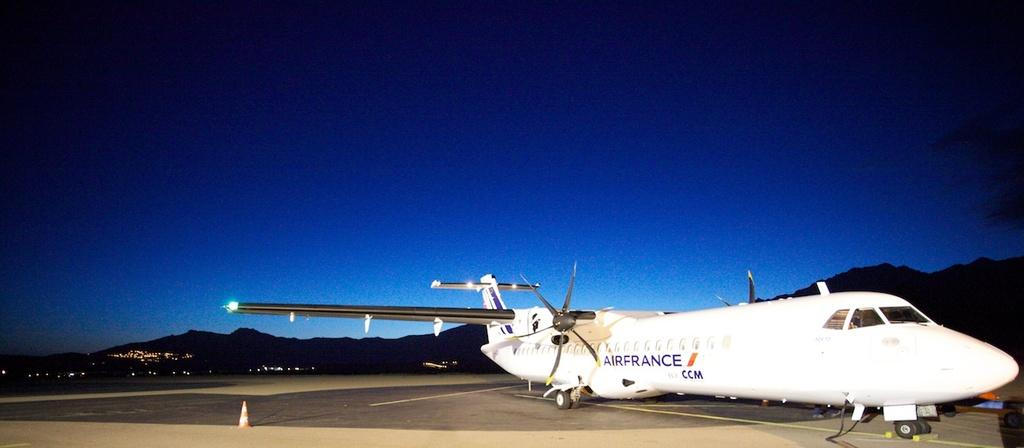<image>
Share a concise interpretation of the image provided. A small white Air France CCM plane sits on the tarmac under the sunset 